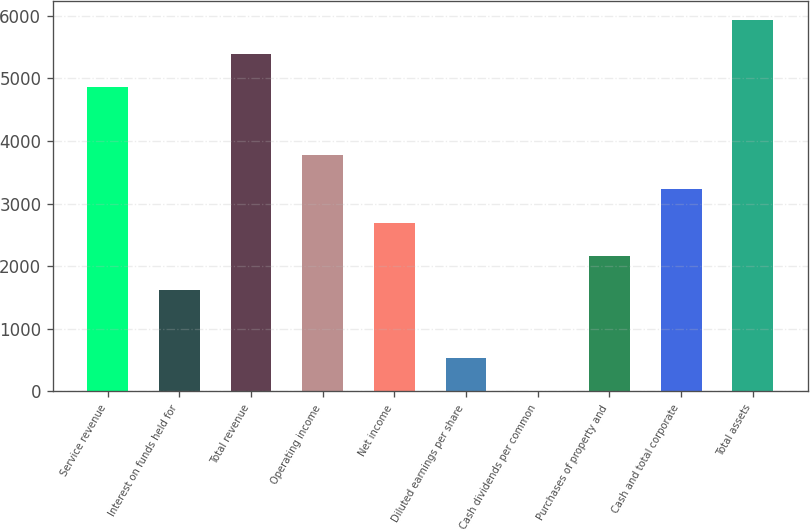<chart> <loc_0><loc_0><loc_500><loc_500><bar_chart><fcel>Service revenue<fcel>Interest on funds held for<fcel>Total revenue<fcel>Operating income<fcel>Net income<fcel>Diluted earnings per share<fcel>Cash dividends per common<fcel>Purchases of property and<fcel>Cash and total corporate<fcel>Total assets<nl><fcel>4854.58<fcel>1619.02<fcel>5393.84<fcel>3776.06<fcel>2697.54<fcel>540.5<fcel>1.24<fcel>2158.28<fcel>3236.8<fcel>5933.1<nl></chart> 